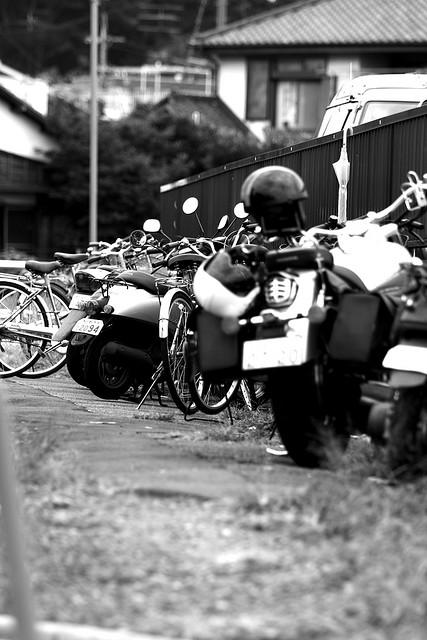What kind of transportation is shown?

Choices:
A) water
B) road
C) air
D) rail road 